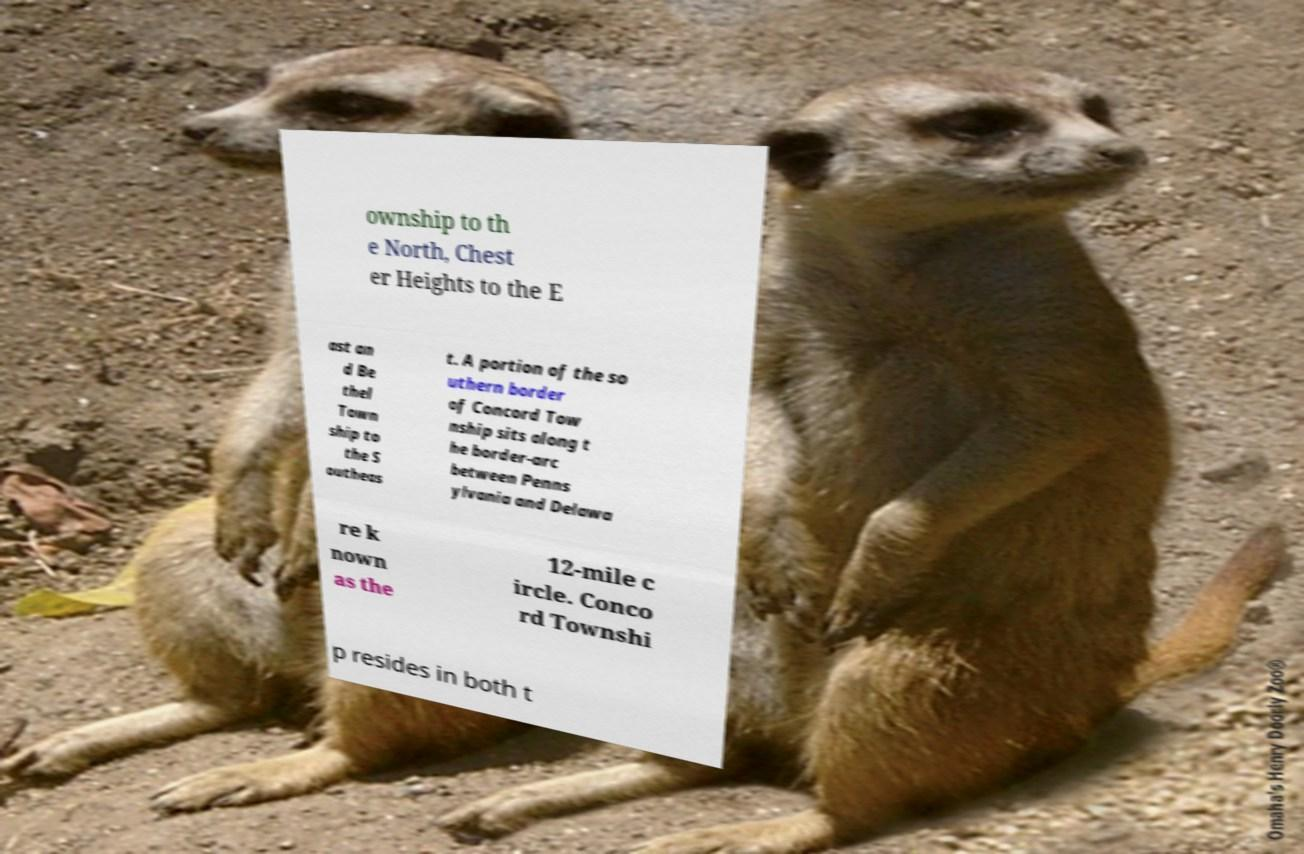Please identify and transcribe the text found in this image. ownship to th e North, Chest er Heights to the E ast an d Be thel Town ship to the S outheas t. A portion of the so uthern border of Concord Tow nship sits along t he border-arc between Penns ylvania and Delawa re k nown as the 12-mile c ircle. Conco rd Townshi p resides in both t 